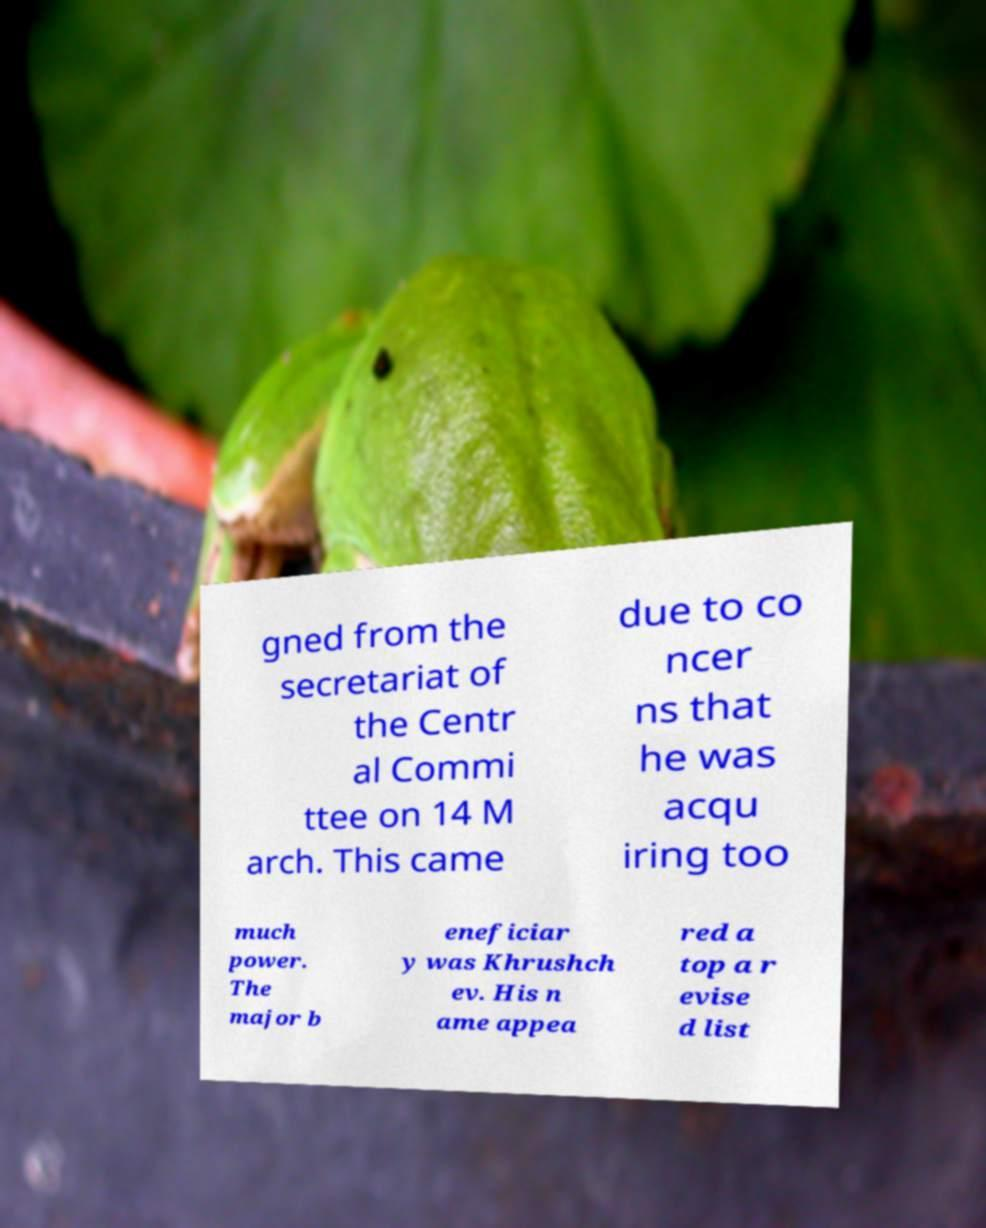There's text embedded in this image that I need extracted. Can you transcribe it verbatim? gned from the secretariat of the Centr al Commi ttee on 14 M arch. This came due to co ncer ns that he was acqu iring too much power. The major b eneficiar y was Khrushch ev. His n ame appea red a top a r evise d list 